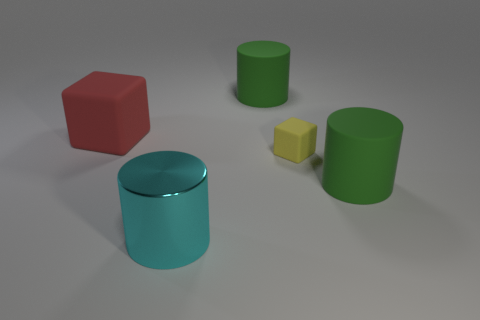Add 1 tiny yellow objects. How many objects exist? 6 Subtract all cubes. How many objects are left? 3 Add 4 tiny yellow things. How many tiny yellow things are left? 5 Add 3 green matte cylinders. How many green matte cylinders exist? 5 Subtract 0 purple cubes. How many objects are left? 5 Subtract all tiny gray things. Subtract all large cyan shiny cylinders. How many objects are left? 4 